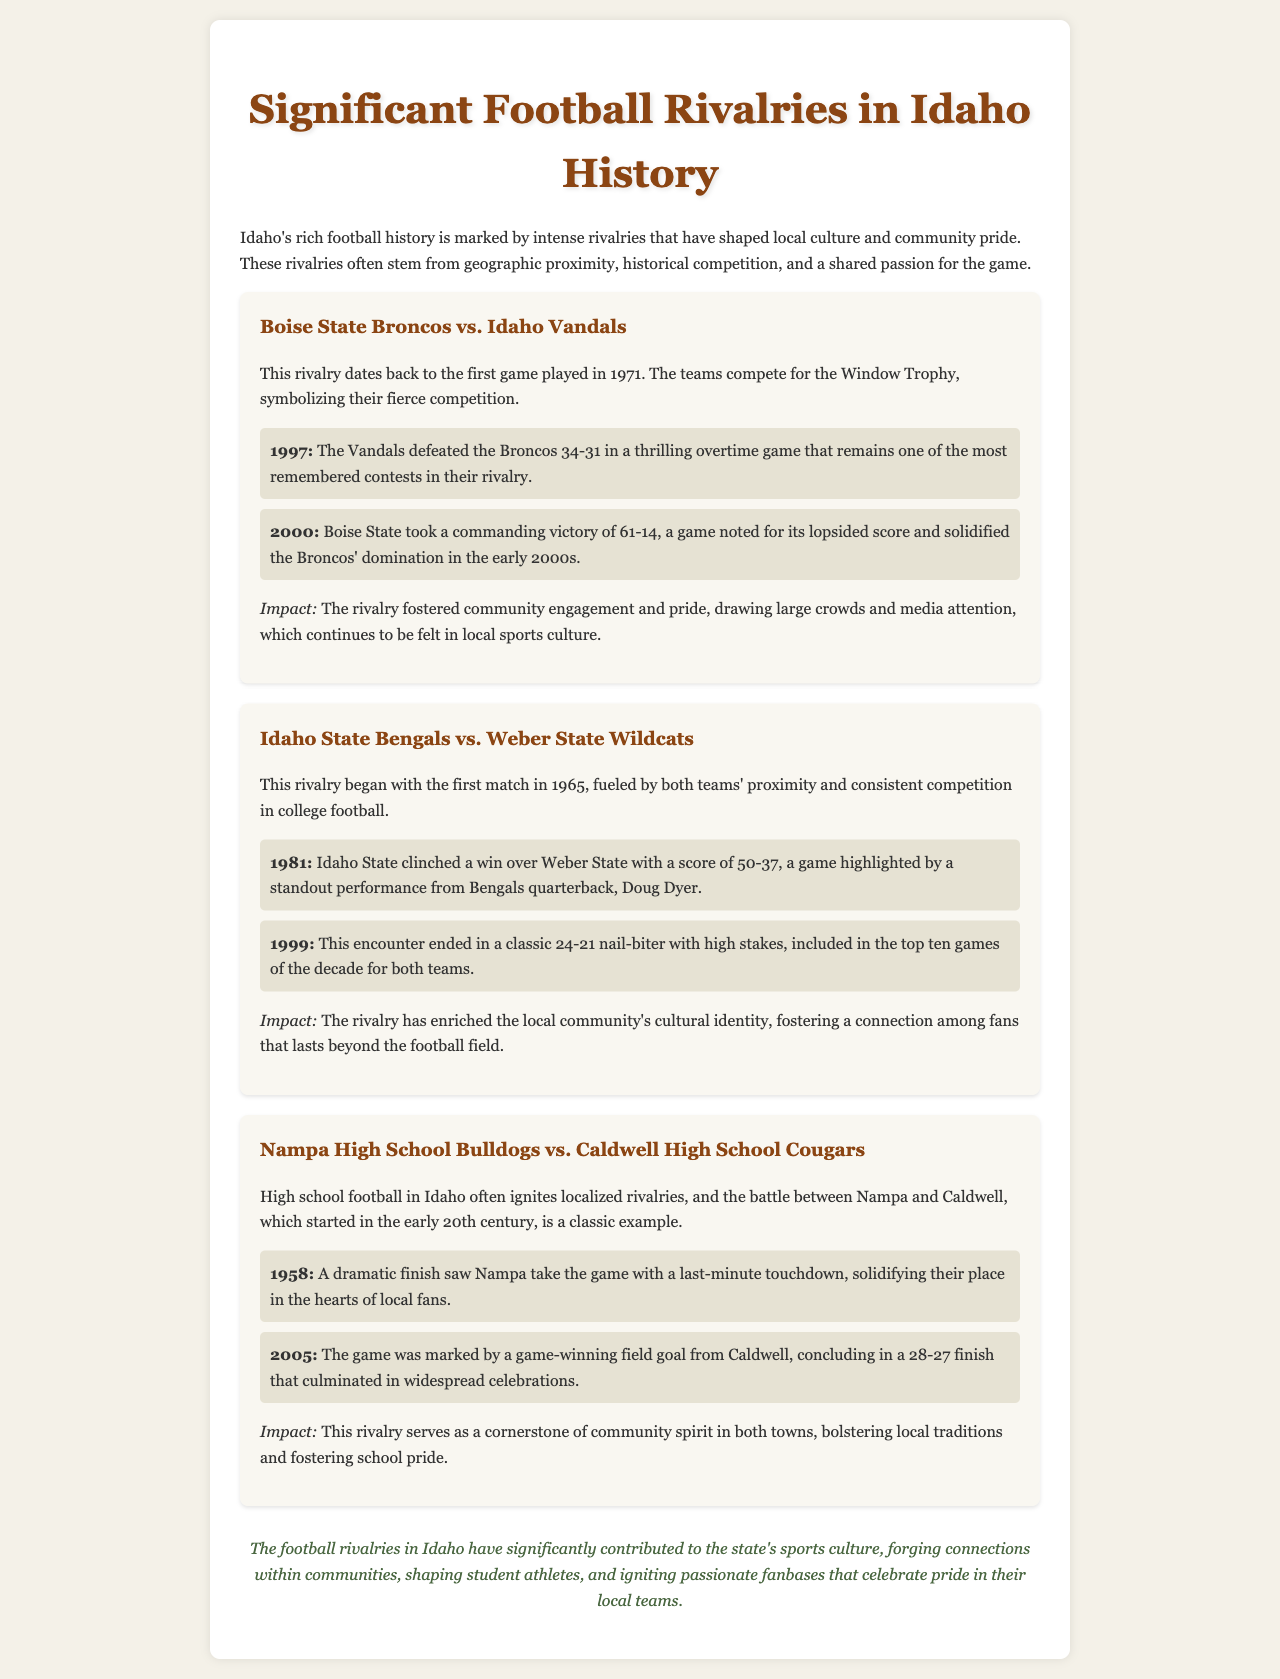What year did the Boise State vs. Idaho Vandals rivalry begin? The rivalry between Boise State and Idaho Vandals began in 1971.
Answer: 1971 What is the Window Trophy? The Window Trophy symbolizes the fierce competition between the Boise State Broncos and Idaho Vandals.
Answer: Window Trophy Which team won the memorable game in 1997 between Boise State and Idaho Vandals? In 1997, the Vandals won against the Broncos with a score of 34-31.
Answer: Vandals How many points did Idaho State score against Weber State in 1981? In 1981, Idaho State scored 50 points against Weber State, winning the game.
Answer: 50 What was the score of the 2005 game between Nampa High School Bulldogs and Caldwell High School Cougars? The final score of the 2005 game was 28-27 in favor of Caldwell.
Answer: 28-27 Which player had a standout performance in the 1981 Idaho State vs. Weber State game? Bengals quarterback Doug Dyer had a standout performance in the 1981 game.
Answer: Doug Dyer What impact did the Boise State vs. Idaho Vandals rivalry have on local culture? The rivalry fostered community engagement and pride, drawing large crowds and media attention.
Answer: Community engagement What year did the Nampa vs. Caldwell rivalry begin? The rivalry between Nampa and Caldwell began in the early 20th century.
Answer: Early 20th century What is a notable aspect of high school football rivalries mentioned in the document? High school football rivalries, like Nampa and Caldwell's, ignite localized community spirit.
Answer: Localized community spirit 